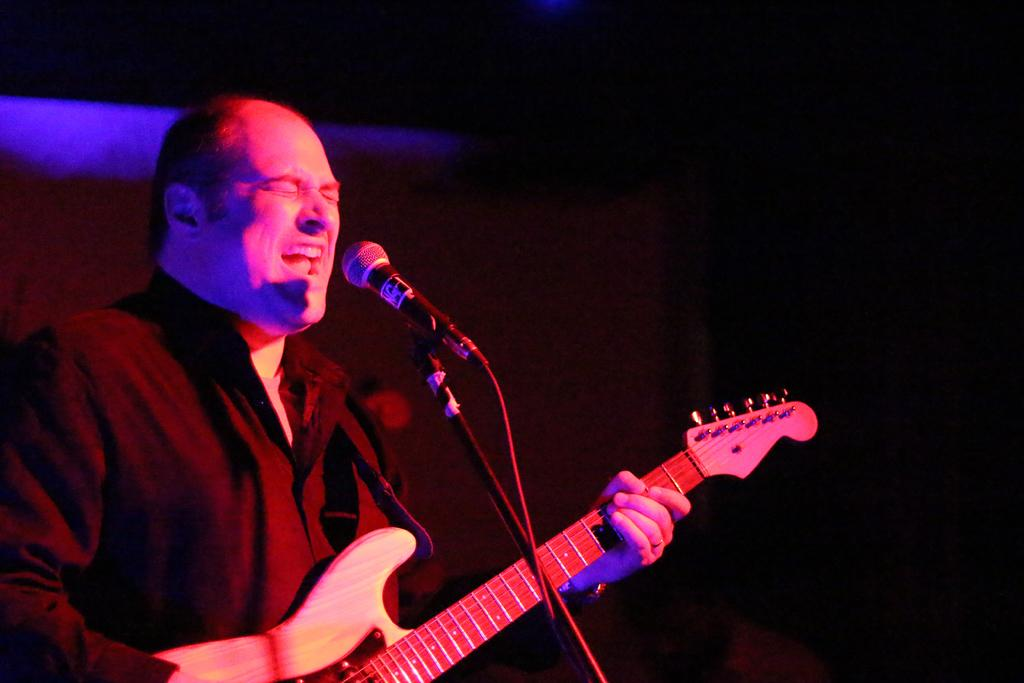What is the color of the background in the image? The background of the image is dark. Who is in the image? There is a man in the image. What is the man doing in the image? The man is singing and playing a guitar. What object is the man standing in front of? The man is in front of a microphone. What type of instrument is the father playing in the image? There is no father present in the image, and the man is playing a guitar, not an instrument associated with a father. 